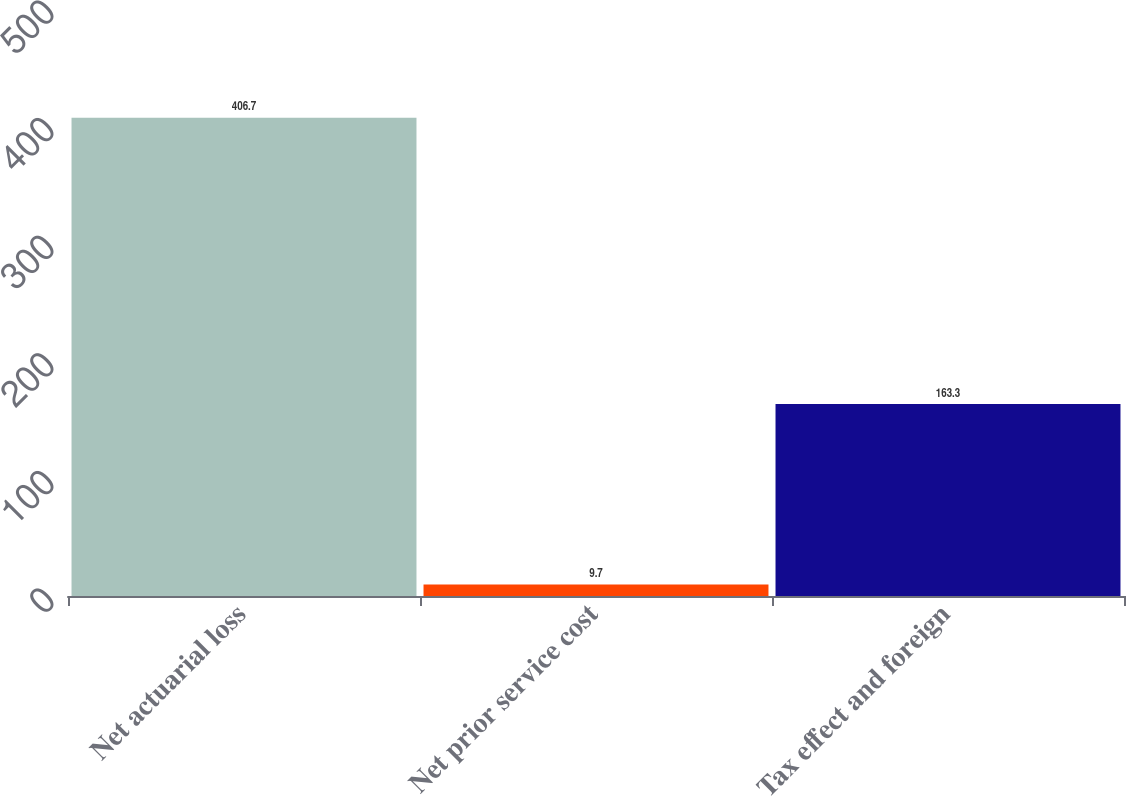Convert chart to OTSL. <chart><loc_0><loc_0><loc_500><loc_500><bar_chart><fcel>Net actuarial loss<fcel>Net prior service cost<fcel>Tax effect and foreign<nl><fcel>406.7<fcel>9.7<fcel>163.3<nl></chart> 